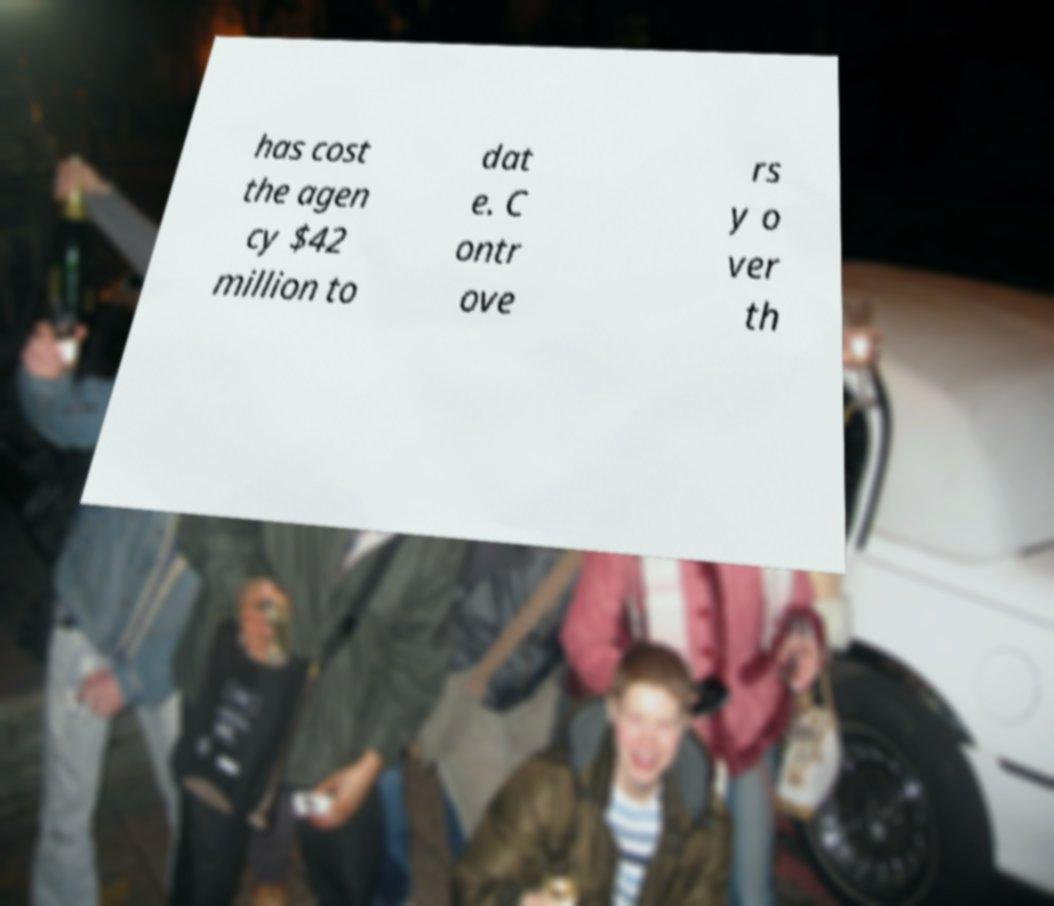For documentation purposes, I need the text within this image transcribed. Could you provide that? has cost the agen cy $42 million to dat e. C ontr ove rs y o ver th 